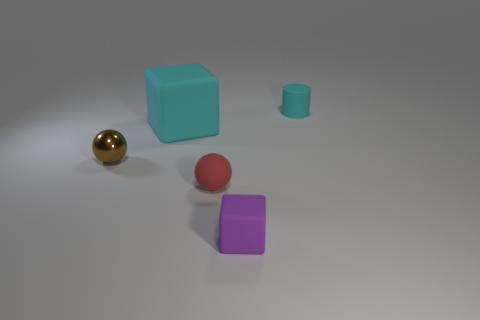What could be the context or setting of this image? This image appears to be a simple scene set up for the purpose of showcasing various geometric shapes and colors. It might be part of a visual or educational material to study shapes, colors, and size relationships between different objects. 